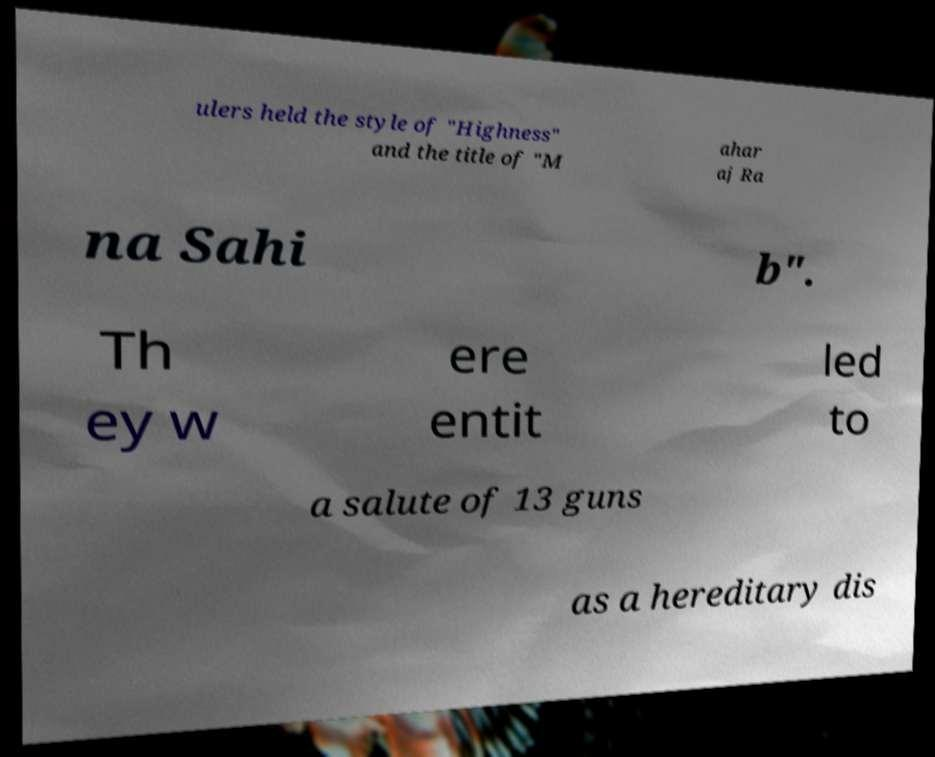Can you read and provide the text displayed in the image?This photo seems to have some interesting text. Can you extract and type it out for me? ulers held the style of "Highness" and the title of "M ahar aj Ra na Sahi b". Th ey w ere entit led to a salute of 13 guns as a hereditary dis 